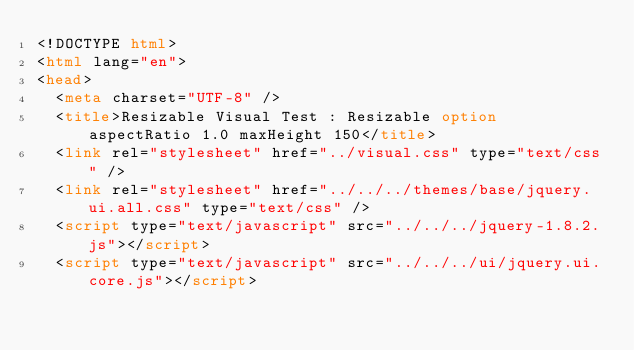<code> <loc_0><loc_0><loc_500><loc_500><_HTML_><!DOCTYPE html>
<html lang="en">
<head>
	<meta charset="UTF-8" />
	<title>Resizable Visual Test : Resizable option aspectRatio 1.0 maxHeight 150</title>
	<link rel="stylesheet" href="../visual.css" type="text/css" />
	<link rel="stylesheet" href="../../../themes/base/jquery.ui.all.css" type="text/css" />
	<script type="text/javascript" src="../../../jquery-1.8.2.js"></script>
	<script type="text/javascript" src="../../../ui/jquery.ui.core.js"></script></code> 